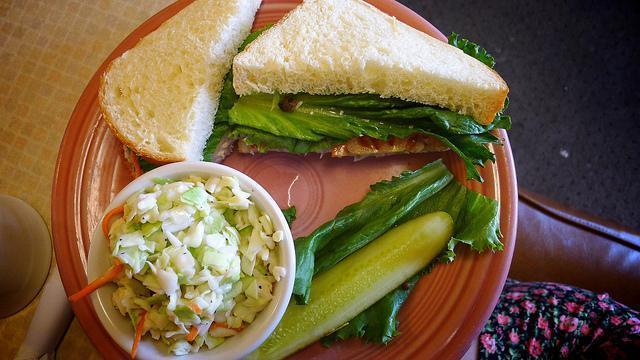Is this affirmation: "The sandwich is at the edge of the couch." correct?
Answer yes or no. Yes. Is this affirmation: "The couch is beneath the sandwich." correct?
Answer yes or no. Yes. 